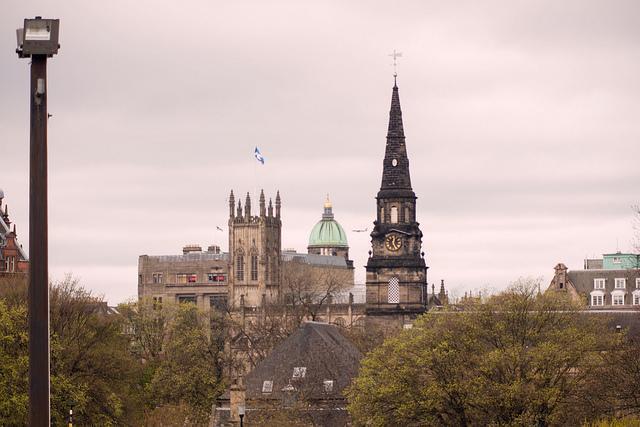What color is the wide dome in the background of the church?
Choose the right answer and clarify with the format: 'Answer: answer
Rationale: rationale.'
Options: Pink, purple, blue copper, red. Answer: blue copper.
Rationale: The dome in the background of this city skyline is a pale blue. 